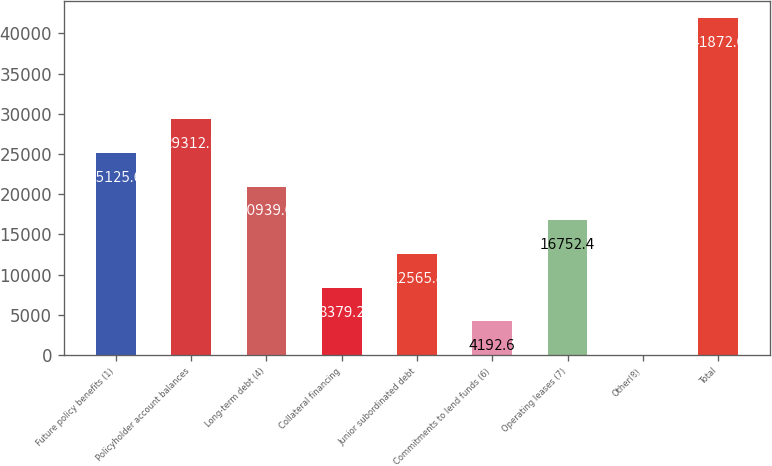Convert chart to OTSL. <chart><loc_0><loc_0><loc_500><loc_500><bar_chart><fcel>Future policy benefits (1)<fcel>Policyholder account balances<fcel>Long-term debt (4)<fcel>Collateral financing<fcel>Junior subordinated debt<fcel>Commitments to lend funds (6)<fcel>Operating leases (7)<fcel>Other(8)<fcel>Total<nl><fcel>25125.6<fcel>29312.2<fcel>20939<fcel>8379.2<fcel>12565.8<fcel>4192.6<fcel>16752.4<fcel>6<fcel>41872<nl></chart> 